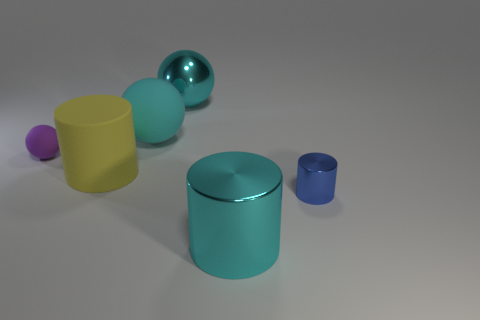What color is the cylinder on the right side of the big metal object that is in front of the big cyan matte sphere?
Offer a very short reply. Blue. What number of objects are either big objects on the right side of the big yellow rubber cylinder or small cyan rubber things?
Provide a short and direct response. 3. There is a blue shiny cylinder; is it the same size as the metallic cylinder that is in front of the blue cylinder?
Give a very brief answer. No. What number of small objects are cyan objects or cyan matte objects?
Your answer should be very brief. 0. There is a tiny purple matte thing; what shape is it?
Make the answer very short. Sphere. There is a matte thing that is the same color as the big metallic cylinder; what size is it?
Give a very brief answer. Large. Is there a small purple sphere made of the same material as the big yellow cylinder?
Give a very brief answer. Yes. Are there more large rubber spheres than large green metallic cubes?
Provide a succinct answer. Yes. Are the purple thing and the big yellow object made of the same material?
Keep it short and to the point. Yes. What number of matte objects are purple things or blue objects?
Make the answer very short. 1. 